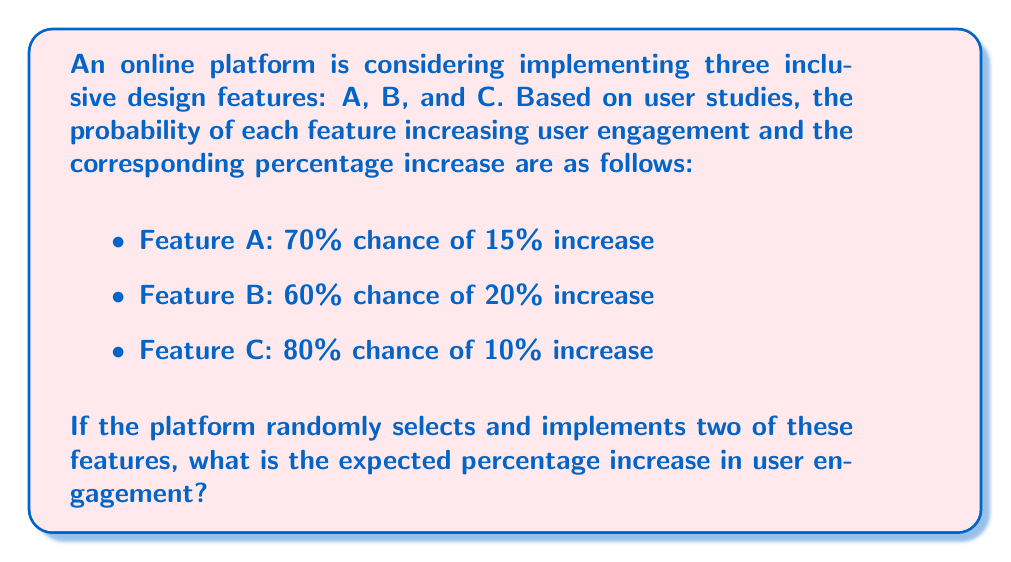Could you help me with this problem? Let's approach this step-by-step:

1) First, we need to calculate the expected value of increase for each feature:

   Feature A: $E(A) = 0.70 \times 15\% + 0.30 \times 0\% = 10.5\%$
   Feature B: $E(B) = 0.60 \times 20\% + 0.40 \times 0\% = 12\%$
   Feature C: $E(C) = 0.80 \times 10\% + 0.20 \times 0\% = 8\%$

2) There are three possible combinations of two features: AB, AC, and BC. Each combination has an equal probability of $\frac{1}{3}$ of being selected.

3) For each combination, we sum the expected values of the two features:

   AB: $E(A) + E(B) = 10.5\% + 12\% = 22.5\%$
   AC: $E(A) + E(C) = 10.5\% + 8\% = 18.5\%$
   BC: $E(B) + E(C) = 12\% + 8\% = 20\%$

4) The overall expected value is the weighted average of these combinations:

   $$E(\text{total}) = \frac{1}{3} \times 22.5\% + \frac{1}{3} \times 18.5\% + \frac{1}{3} \times 20\%$$

5) Simplifying:

   $$E(\text{total}) = \frac{22.5\% + 18.5\% + 20\%}{3} = \frac{61\%}{3} = 20.33\%$$

Thus, the expected percentage increase in user engagement is 20.33%.
Answer: 20.33% 